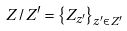<formula> <loc_0><loc_0><loc_500><loc_500>Z / Z ^ { \prime } = \left \{ Z _ { z ^ { \prime } } \right \} _ { z ^ { \prime } \in Z ^ { \prime } }</formula> 